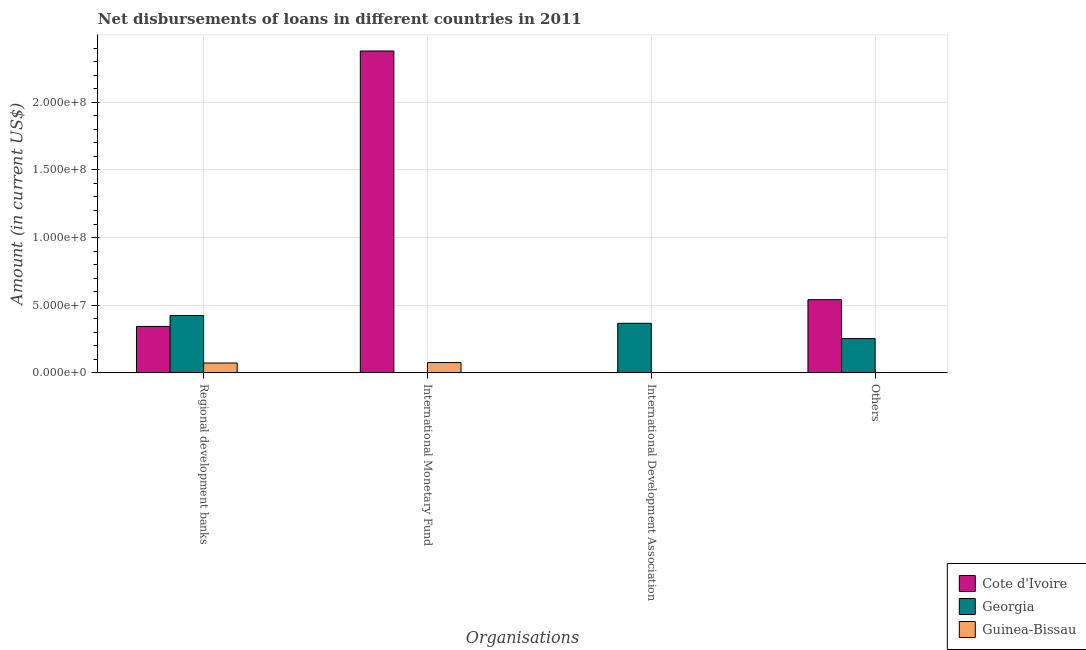How many bars are there on the 2nd tick from the right?
Your response must be concise. 1. What is the label of the 1st group of bars from the left?
Make the answer very short. Regional development banks. What is the amount of loan disimbursed by international monetary fund in Cote d'Ivoire?
Give a very brief answer. 2.38e+08. Across all countries, what is the maximum amount of loan disimbursed by international monetary fund?
Your answer should be compact. 2.38e+08. In which country was the amount of loan disimbursed by other organisations maximum?
Provide a short and direct response. Cote d'Ivoire. What is the total amount of loan disimbursed by other organisations in the graph?
Provide a short and direct response. 7.95e+07. What is the difference between the amount of loan disimbursed by regional development banks in Guinea-Bissau and that in Georgia?
Give a very brief answer. -3.51e+07. What is the difference between the amount of loan disimbursed by regional development banks in Georgia and the amount of loan disimbursed by other organisations in Cote d'Ivoire?
Provide a short and direct response. -1.17e+07. What is the average amount of loan disimbursed by other organisations per country?
Make the answer very short. 2.65e+07. What is the difference between the amount of loan disimbursed by international monetary fund and amount of loan disimbursed by regional development banks in Cote d'Ivoire?
Ensure brevity in your answer.  2.04e+08. In how many countries, is the amount of loan disimbursed by international development association greater than 140000000 US$?
Give a very brief answer. 0. What is the ratio of the amount of loan disimbursed by regional development banks in Guinea-Bissau to that in Cote d'Ivoire?
Provide a short and direct response. 0.21. What is the difference between the highest and the second highest amount of loan disimbursed by regional development banks?
Give a very brief answer. 8.04e+06. What is the difference between the highest and the lowest amount of loan disimbursed by international monetary fund?
Your answer should be very brief. 2.38e+08. In how many countries, is the amount of loan disimbursed by other organisations greater than the average amount of loan disimbursed by other organisations taken over all countries?
Offer a very short reply. 1. Is it the case that in every country, the sum of the amount of loan disimbursed by regional development banks and amount of loan disimbursed by international monetary fund is greater than the amount of loan disimbursed by international development association?
Provide a succinct answer. Yes. Are the values on the major ticks of Y-axis written in scientific E-notation?
Provide a short and direct response. Yes. Does the graph contain grids?
Provide a short and direct response. Yes. Where does the legend appear in the graph?
Your answer should be very brief. Bottom right. How many legend labels are there?
Your answer should be very brief. 3. How are the legend labels stacked?
Ensure brevity in your answer.  Vertical. What is the title of the graph?
Offer a terse response. Net disbursements of loans in different countries in 2011. What is the label or title of the X-axis?
Ensure brevity in your answer.  Organisations. What is the Amount (in current US$) in Cote d'Ivoire in Regional development banks?
Keep it short and to the point. 3.43e+07. What is the Amount (in current US$) of Georgia in Regional development banks?
Your answer should be compact. 4.24e+07. What is the Amount (in current US$) of Guinea-Bissau in Regional development banks?
Your answer should be compact. 7.28e+06. What is the Amount (in current US$) in Cote d'Ivoire in International Monetary Fund?
Give a very brief answer. 2.38e+08. What is the Amount (in current US$) of Georgia in International Monetary Fund?
Provide a succinct answer. 0. What is the Amount (in current US$) in Guinea-Bissau in International Monetary Fund?
Provide a succinct answer. 7.61e+06. What is the Amount (in current US$) of Cote d'Ivoire in International Development Association?
Your response must be concise. 0. What is the Amount (in current US$) in Georgia in International Development Association?
Offer a very short reply. 3.66e+07. What is the Amount (in current US$) of Guinea-Bissau in International Development Association?
Keep it short and to the point. 0. What is the Amount (in current US$) in Cote d'Ivoire in Others?
Provide a short and direct response. 5.41e+07. What is the Amount (in current US$) in Georgia in Others?
Keep it short and to the point. 2.53e+07. What is the Amount (in current US$) in Guinea-Bissau in Others?
Ensure brevity in your answer.  0. Across all Organisations, what is the maximum Amount (in current US$) in Cote d'Ivoire?
Your answer should be very brief. 2.38e+08. Across all Organisations, what is the maximum Amount (in current US$) in Georgia?
Your response must be concise. 4.24e+07. Across all Organisations, what is the maximum Amount (in current US$) in Guinea-Bissau?
Keep it short and to the point. 7.61e+06. Across all Organisations, what is the minimum Amount (in current US$) of Guinea-Bissau?
Your response must be concise. 0. What is the total Amount (in current US$) in Cote d'Ivoire in the graph?
Make the answer very short. 3.26e+08. What is the total Amount (in current US$) of Georgia in the graph?
Provide a succinct answer. 1.04e+08. What is the total Amount (in current US$) in Guinea-Bissau in the graph?
Your response must be concise. 1.49e+07. What is the difference between the Amount (in current US$) of Cote d'Ivoire in Regional development banks and that in International Monetary Fund?
Give a very brief answer. -2.04e+08. What is the difference between the Amount (in current US$) of Guinea-Bissau in Regional development banks and that in International Monetary Fund?
Provide a succinct answer. -3.28e+05. What is the difference between the Amount (in current US$) of Georgia in Regional development banks and that in International Development Association?
Provide a short and direct response. 5.72e+06. What is the difference between the Amount (in current US$) in Cote d'Ivoire in Regional development banks and that in Others?
Ensure brevity in your answer.  -1.98e+07. What is the difference between the Amount (in current US$) in Georgia in Regional development banks and that in Others?
Ensure brevity in your answer.  1.70e+07. What is the difference between the Amount (in current US$) in Cote d'Ivoire in International Monetary Fund and that in Others?
Your answer should be very brief. 1.84e+08. What is the difference between the Amount (in current US$) in Georgia in International Development Association and that in Others?
Your answer should be compact. 1.13e+07. What is the difference between the Amount (in current US$) in Cote d'Ivoire in Regional development banks and the Amount (in current US$) in Guinea-Bissau in International Monetary Fund?
Your answer should be compact. 2.67e+07. What is the difference between the Amount (in current US$) in Georgia in Regional development banks and the Amount (in current US$) in Guinea-Bissau in International Monetary Fund?
Provide a short and direct response. 3.47e+07. What is the difference between the Amount (in current US$) in Cote d'Ivoire in Regional development banks and the Amount (in current US$) in Georgia in International Development Association?
Give a very brief answer. -2.32e+06. What is the difference between the Amount (in current US$) in Cote d'Ivoire in Regional development banks and the Amount (in current US$) in Georgia in Others?
Offer a very short reply. 8.98e+06. What is the difference between the Amount (in current US$) of Cote d'Ivoire in International Monetary Fund and the Amount (in current US$) of Georgia in International Development Association?
Ensure brevity in your answer.  2.01e+08. What is the difference between the Amount (in current US$) of Cote d'Ivoire in International Monetary Fund and the Amount (in current US$) of Georgia in Others?
Provide a succinct answer. 2.13e+08. What is the average Amount (in current US$) of Cote d'Ivoire per Organisations?
Your answer should be very brief. 8.16e+07. What is the average Amount (in current US$) of Georgia per Organisations?
Offer a very short reply. 2.61e+07. What is the average Amount (in current US$) in Guinea-Bissau per Organisations?
Give a very brief answer. 3.72e+06. What is the difference between the Amount (in current US$) of Cote d'Ivoire and Amount (in current US$) of Georgia in Regional development banks?
Offer a very short reply. -8.04e+06. What is the difference between the Amount (in current US$) in Cote d'Ivoire and Amount (in current US$) in Guinea-Bissau in Regional development banks?
Provide a short and direct response. 2.70e+07. What is the difference between the Amount (in current US$) in Georgia and Amount (in current US$) in Guinea-Bissau in Regional development banks?
Your answer should be very brief. 3.51e+07. What is the difference between the Amount (in current US$) of Cote d'Ivoire and Amount (in current US$) of Guinea-Bissau in International Monetary Fund?
Offer a very short reply. 2.30e+08. What is the difference between the Amount (in current US$) of Cote d'Ivoire and Amount (in current US$) of Georgia in Others?
Your answer should be very brief. 2.88e+07. What is the ratio of the Amount (in current US$) of Cote d'Ivoire in Regional development banks to that in International Monetary Fund?
Ensure brevity in your answer.  0.14. What is the ratio of the Amount (in current US$) in Guinea-Bissau in Regional development banks to that in International Monetary Fund?
Keep it short and to the point. 0.96. What is the ratio of the Amount (in current US$) of Georgia in Regional development banks to that in International Development Association?
Make the answer very short. 1.16. What is the ratio of the Amount (in current US$) in Cote d'Ivoire in Regional development banks to that in Others?
Keep it short and to the point. 0.63. What is the ratio of the Amount (in current US$) of Georgia in Regional development banks to that in Others?
Offer a very short reply. 1.67. What is the ratio of the Amount (in current US$) of Cote d'Ivoire in International Monetary Fund to that in Others?
Your answer should be compact. 4.4. What is the ratio of the Amount (in current US$) of Georgia in International Development Association to that in Others?
Give a very brief answer. 1.45. What is the difference between the highest and the second highest Amount (in current US$) of Cote d'Ivoire?
Offer a very short reply. 1.84e+08. What is the difference between the highest and the second highest Amount (in current US$) of Georgia?
Ensure brevity in your answer.  5.72e+06. What is the difference between the highest and the lowest Amount (in current US$) of Cote d'Ivoire?
Ensure brevity in your answer.  2.38e+08. What is the difference between the highest and the lowest Amount (in current US$) in Georgia?
Your answer should be compact. 4.24e+07. What is the difference between the highest and the lowest Amount (in current US$) of Guinea-Bissau?
Your answer should be very brief. 7.61e+06. 